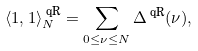<formula> <loc_0><loc_0><loc_500><loc_500>\langle 1 , 1 \rangle _ { N } ^ { \text { qR} } = \sum _ { 0 \leq \nu \leq N } \Delta ^ { \text { qR} } ( \nu ) ,</formula> 